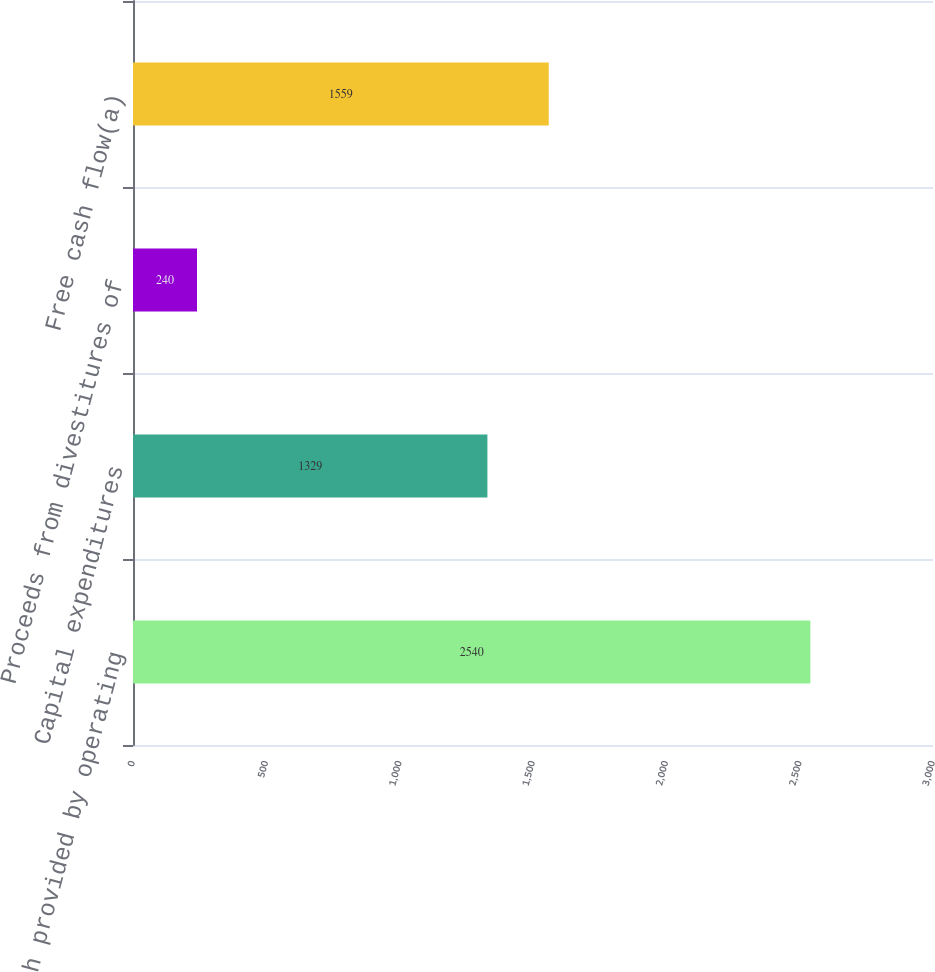<chart> <loc_0><loc_0><loc_500><loc_500><bar_chart><fcel>Net cash provided by operating<fcel>Capital expenditures<fcel>Proceeds from divestitures of<fcel>Free cash flow(a)<nl><fcel>2540<fcel>1329<fcel>240<fcel>1559<nl></chart> 